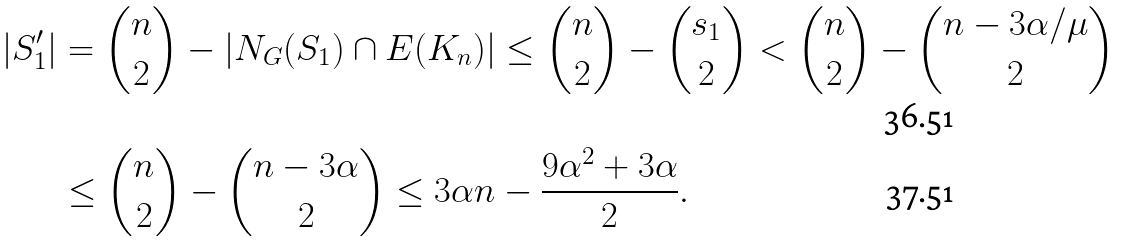<formula> <loc_0><loc_0><loc_500><loc_500>| S _ { 1 } ^ { \prime } | & = \binom { n } { 2 } - \left | N _ { G } { ( S _ { 1 } ) } \cap E ( K _ { n } ) \right | \leq \binom { n } { 2 } - \binom { s _ { 1 } } { 2 } < \binom { n } { 2 } - \binom { n - 3 \alpha / \mu } { 2 } \\ & \leq \binom { n } { 2 } - \binom { n - 3 \alpha } { 2 } \leq 3 \alpha n - \frac { 9 \alpha ^ { 2 } + 3 \alpha } { 2 } .</formula> 